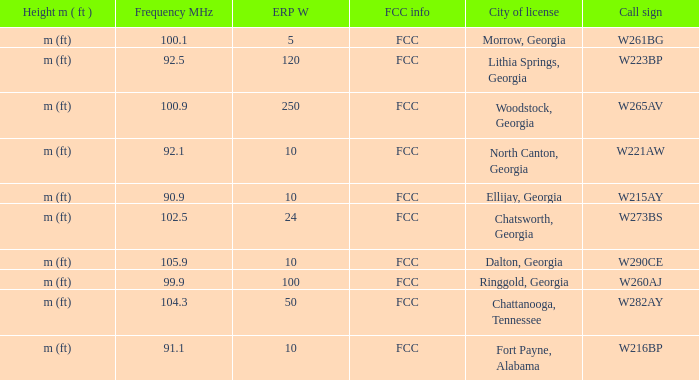How many ERP W is it that has a Call sign of w273bs? 24.0. 